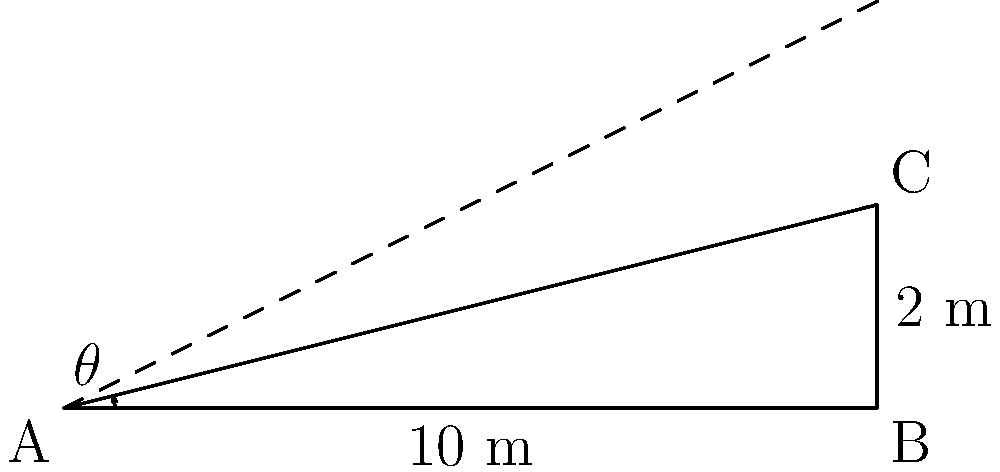In the popular comedy theater "Smekh i Tochka," a new sloped stage is being designed for a skit about mountain climbing. The stage is 10 meters long and rises to a height of 2 meters at its highest point. What is the angle of inclination (θ) of the stage in degrees? To find the angle of inclination, we need to use trigonometry. Let's approach this step-by-step:

1) We have a right triangle where:
   - The base (adjacent side) is 10 meters
   - The height (opposite side) is 2 meters
   - We need to find the angle θ

2) In this case, we can use the tangent function, which is defined as:

   $$\tan(\theta) = \frac{\text{opposite}}{\text{adjacent}}$$

3) Substituting our values:

   $$\tan(\theta) = \frac{2}{10} = 0.2$$

4) To find θ, we need to take the inverse tangent (arctan or tan^(-1)):

   $$\theta = \tan^{-1}(0.2)$$

5) Using a calculator or trigonometric tables:

   $$\theta \approx 11.31^\circ$$

6) Rounding to the nearest degree:

   $$\theta \approx 11^\circ$$

Thus, the angle of inclination of the stage is approximately 11 degrees.
Answer: 11° 